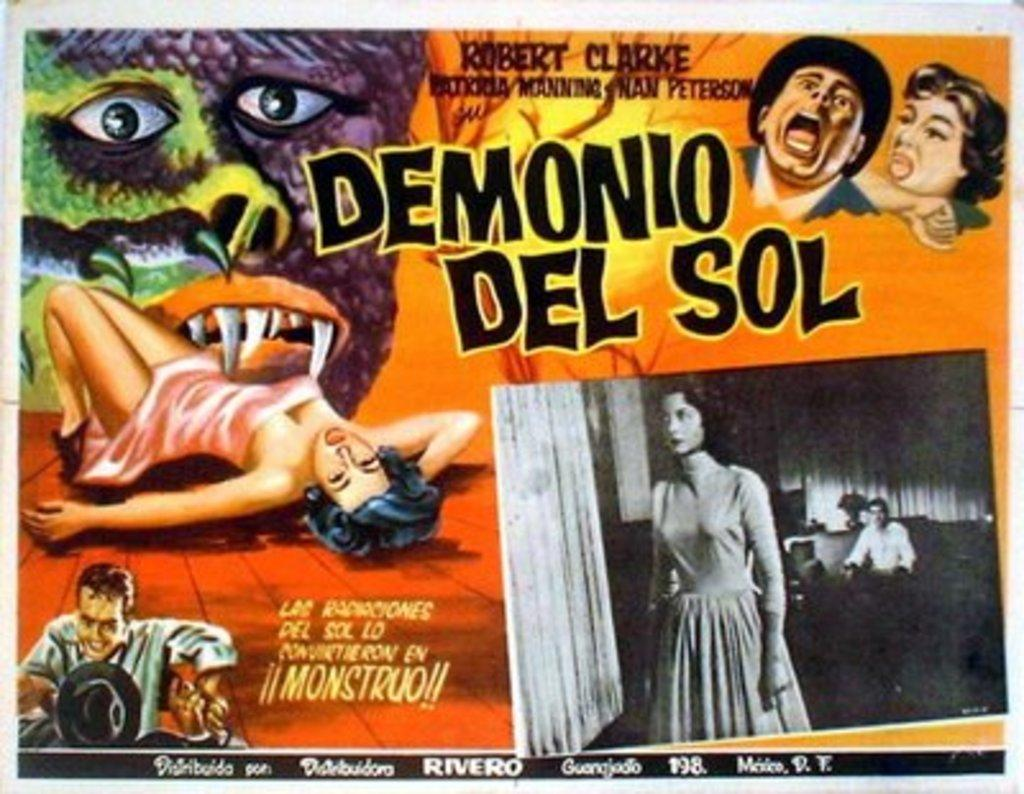<image>
Write a terse but informative summary of the picture. Robert Clark stars in a movie called Demonio Del Sol 